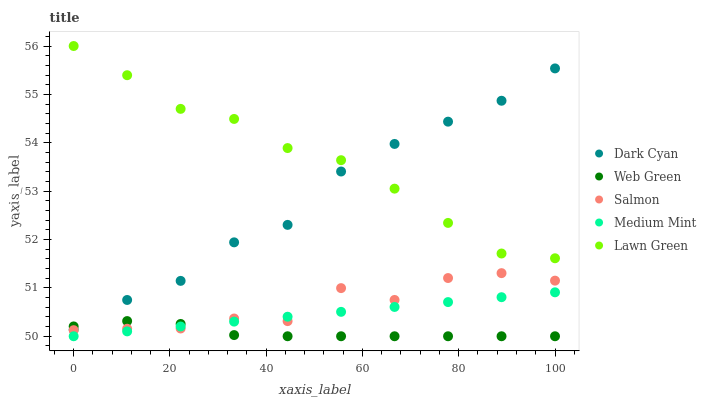Does Web Green have the minimum area under the curve?
Answer yes or no. Yes. Does Lawn Green have the maximum area under the curve?
Answer yes or no. Yes. Does Medium Mint have the minimum area under the curve?
Answer yes or no. No. Does Medium Mint have the maximum area under the curve?
Answer yes or no. No. Is Medium Mint the smoothest?
Answer yes or no. Yes. Is Salmon the roughest?
Answer yes or no. Yes. Is Salmon the smoothest?
Answer yes or no. No. Is Medium Mint the roughest?
Answer yes or no. No. Does Medium Mint have the lowest value?
Answer yes or no. Yes. Does Salmon have the lowest value?
Answer yes or no. No. Does Lawn Green have the highest value?
Answer yes or no. Yes. Does Medium Mint have the highest value?
Answer yes or no. No. Is Web Green less than Lawn Green?
Answer yes or no. Yes. Is Dark Cyan greater than Medium Mint?
Answer yes or no. Yes. Does Lawn Green intersect Dark Cyan?
Answer yes or no. Yes. Is Lawn Green less than Dark Cyan?
Answer yes or no. No. Is Lawn Green greater than Dark Cyan?
Answer yes or no. No. Does Web Green intersect Lawn Green?
Answer yes or no. No. 